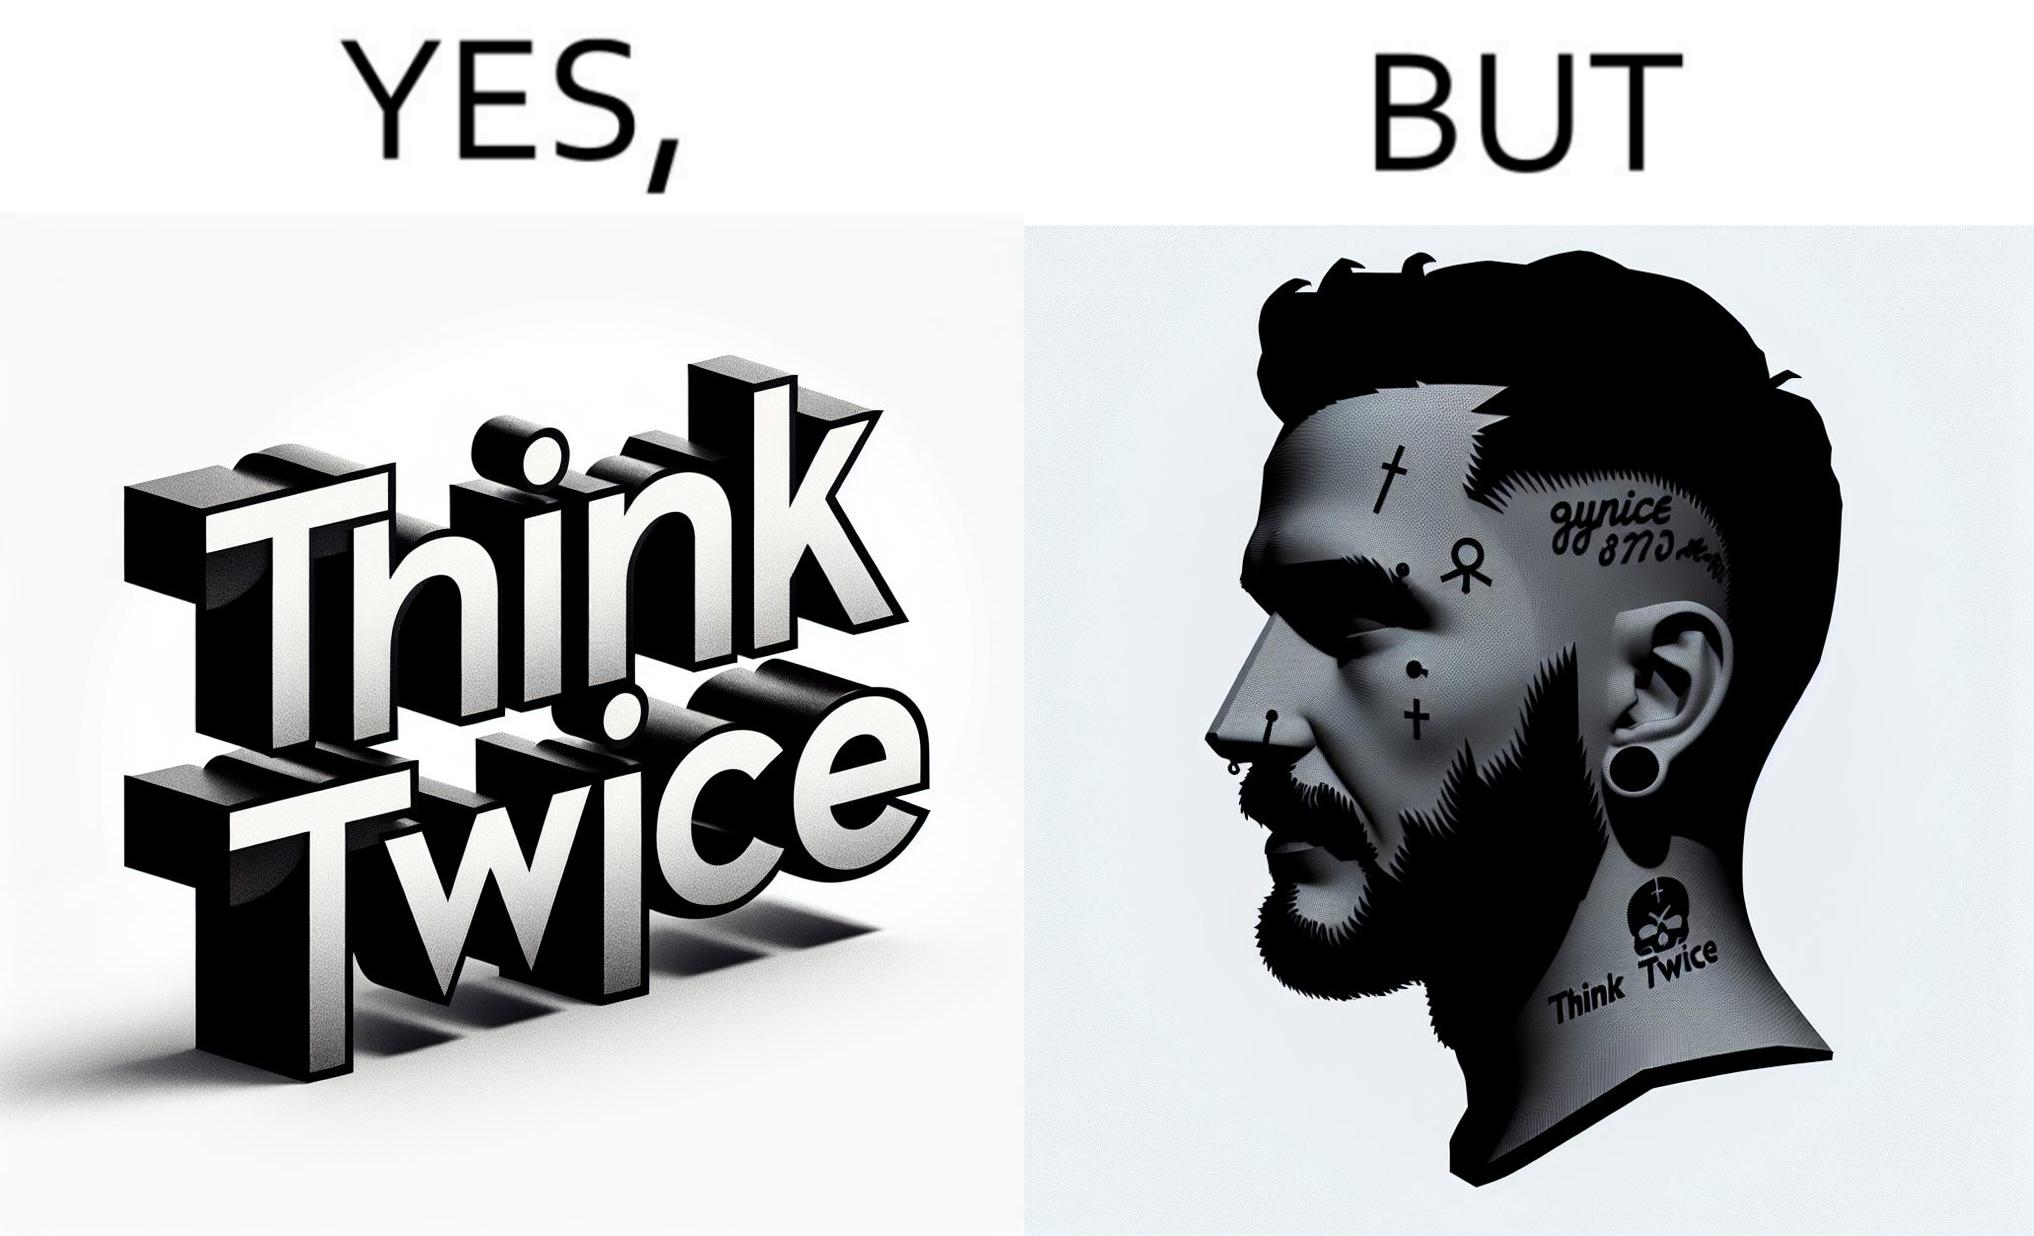What does this image depict? The image is funny because even thought the tattoo on the face of the man says "think twice", the man did not think twice before getting the tattoo on his forehead. 